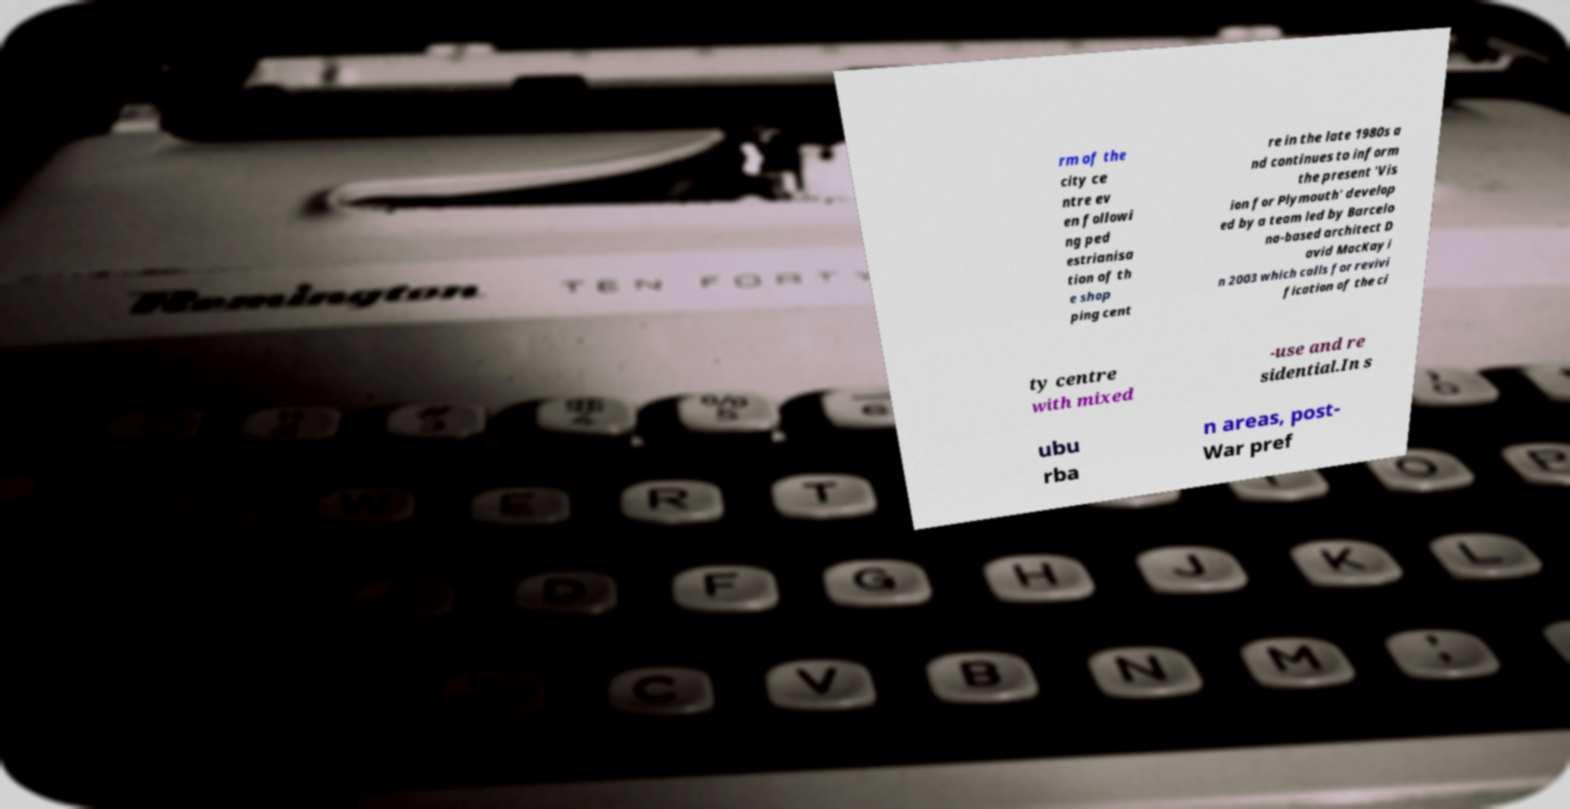Can you accurately transcribe the text from the provided image for me? rm of the city ce ntre ev en followi ng ped estrianisa tion of th e shop ping cent re in the late 1980s a nd continues to inform the present 'Vis ion for Plymouth' develop ed by a team led by Barcelo na-based architect D avid MacKay i n 2003 which calls for revivi fication of the ci ty centre with mixed -use and re sidential.In s ubu rba n areas, post- War pref 